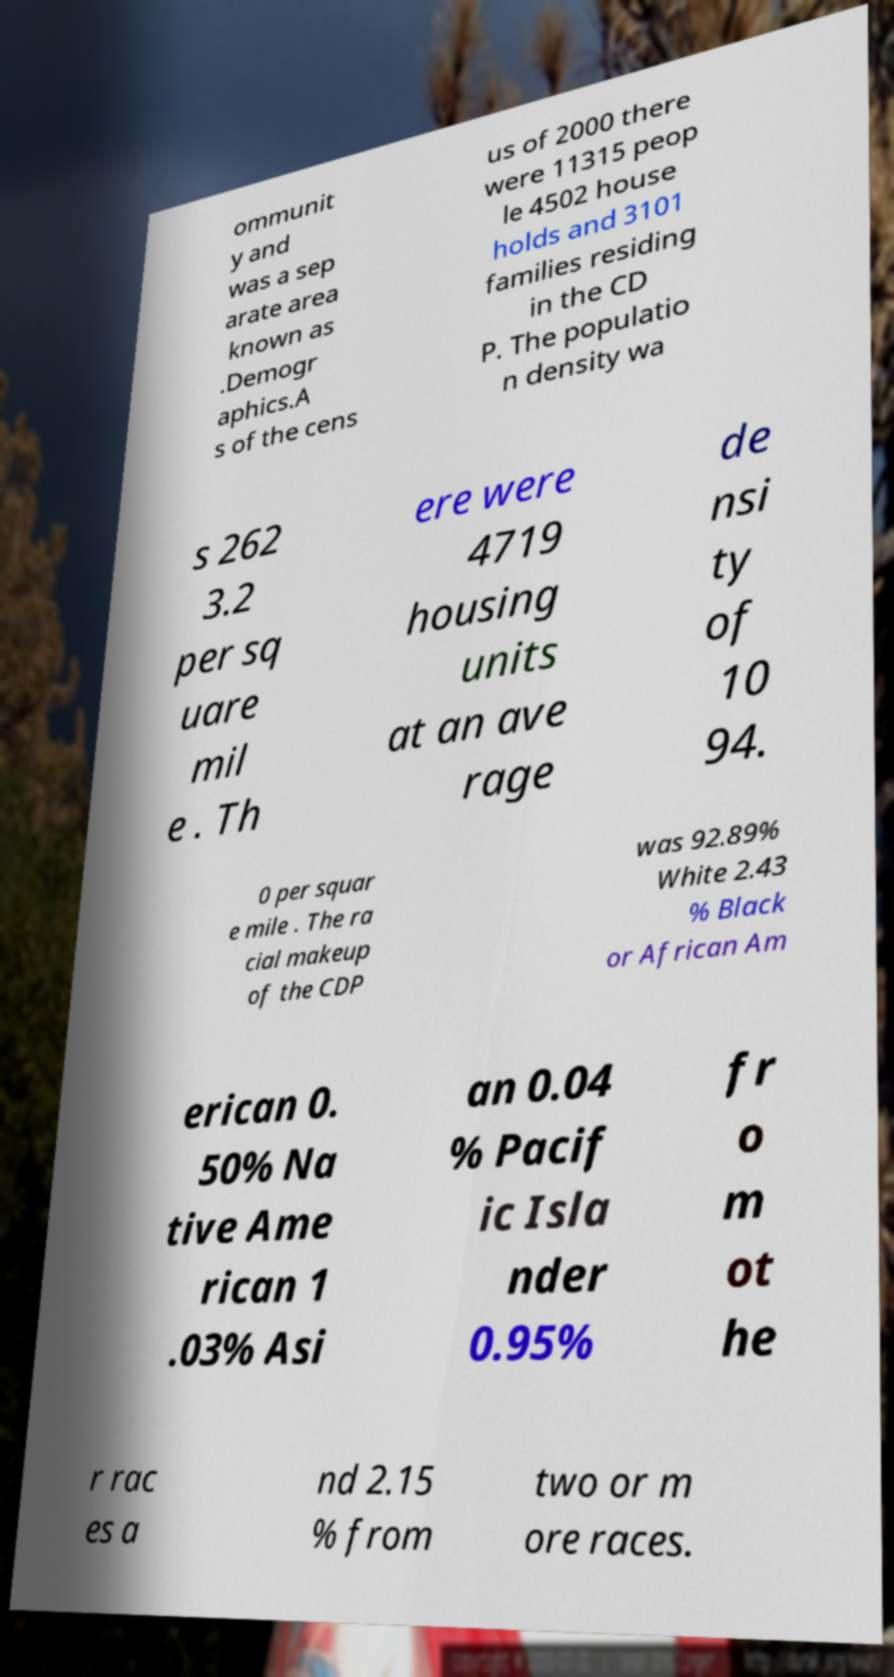Please identify and transcribe the text found in this image. ommunit y and was a sep arate area known as .Demogr aphics.A s of the cens us of 2000 there were 11315 peop le 4502 house holds and 3101 families residing in the CD P. The populatio n density wa s 262 3.2 per sq uare mil e . Th ere were 4719 housing units at an ave rage de nsi ty of 10 94. 0 per squar e mile . The ra cial makeup of the CDP was 92.89% White 2.43 % Black or African Am erican 0. 50% Na tive Ame rican 1 .03% Asi an 0.04 % Pacif ic Isla nder 0.95% fr o m ot he r rac es a nd 2.15 % from two or m ore races. 